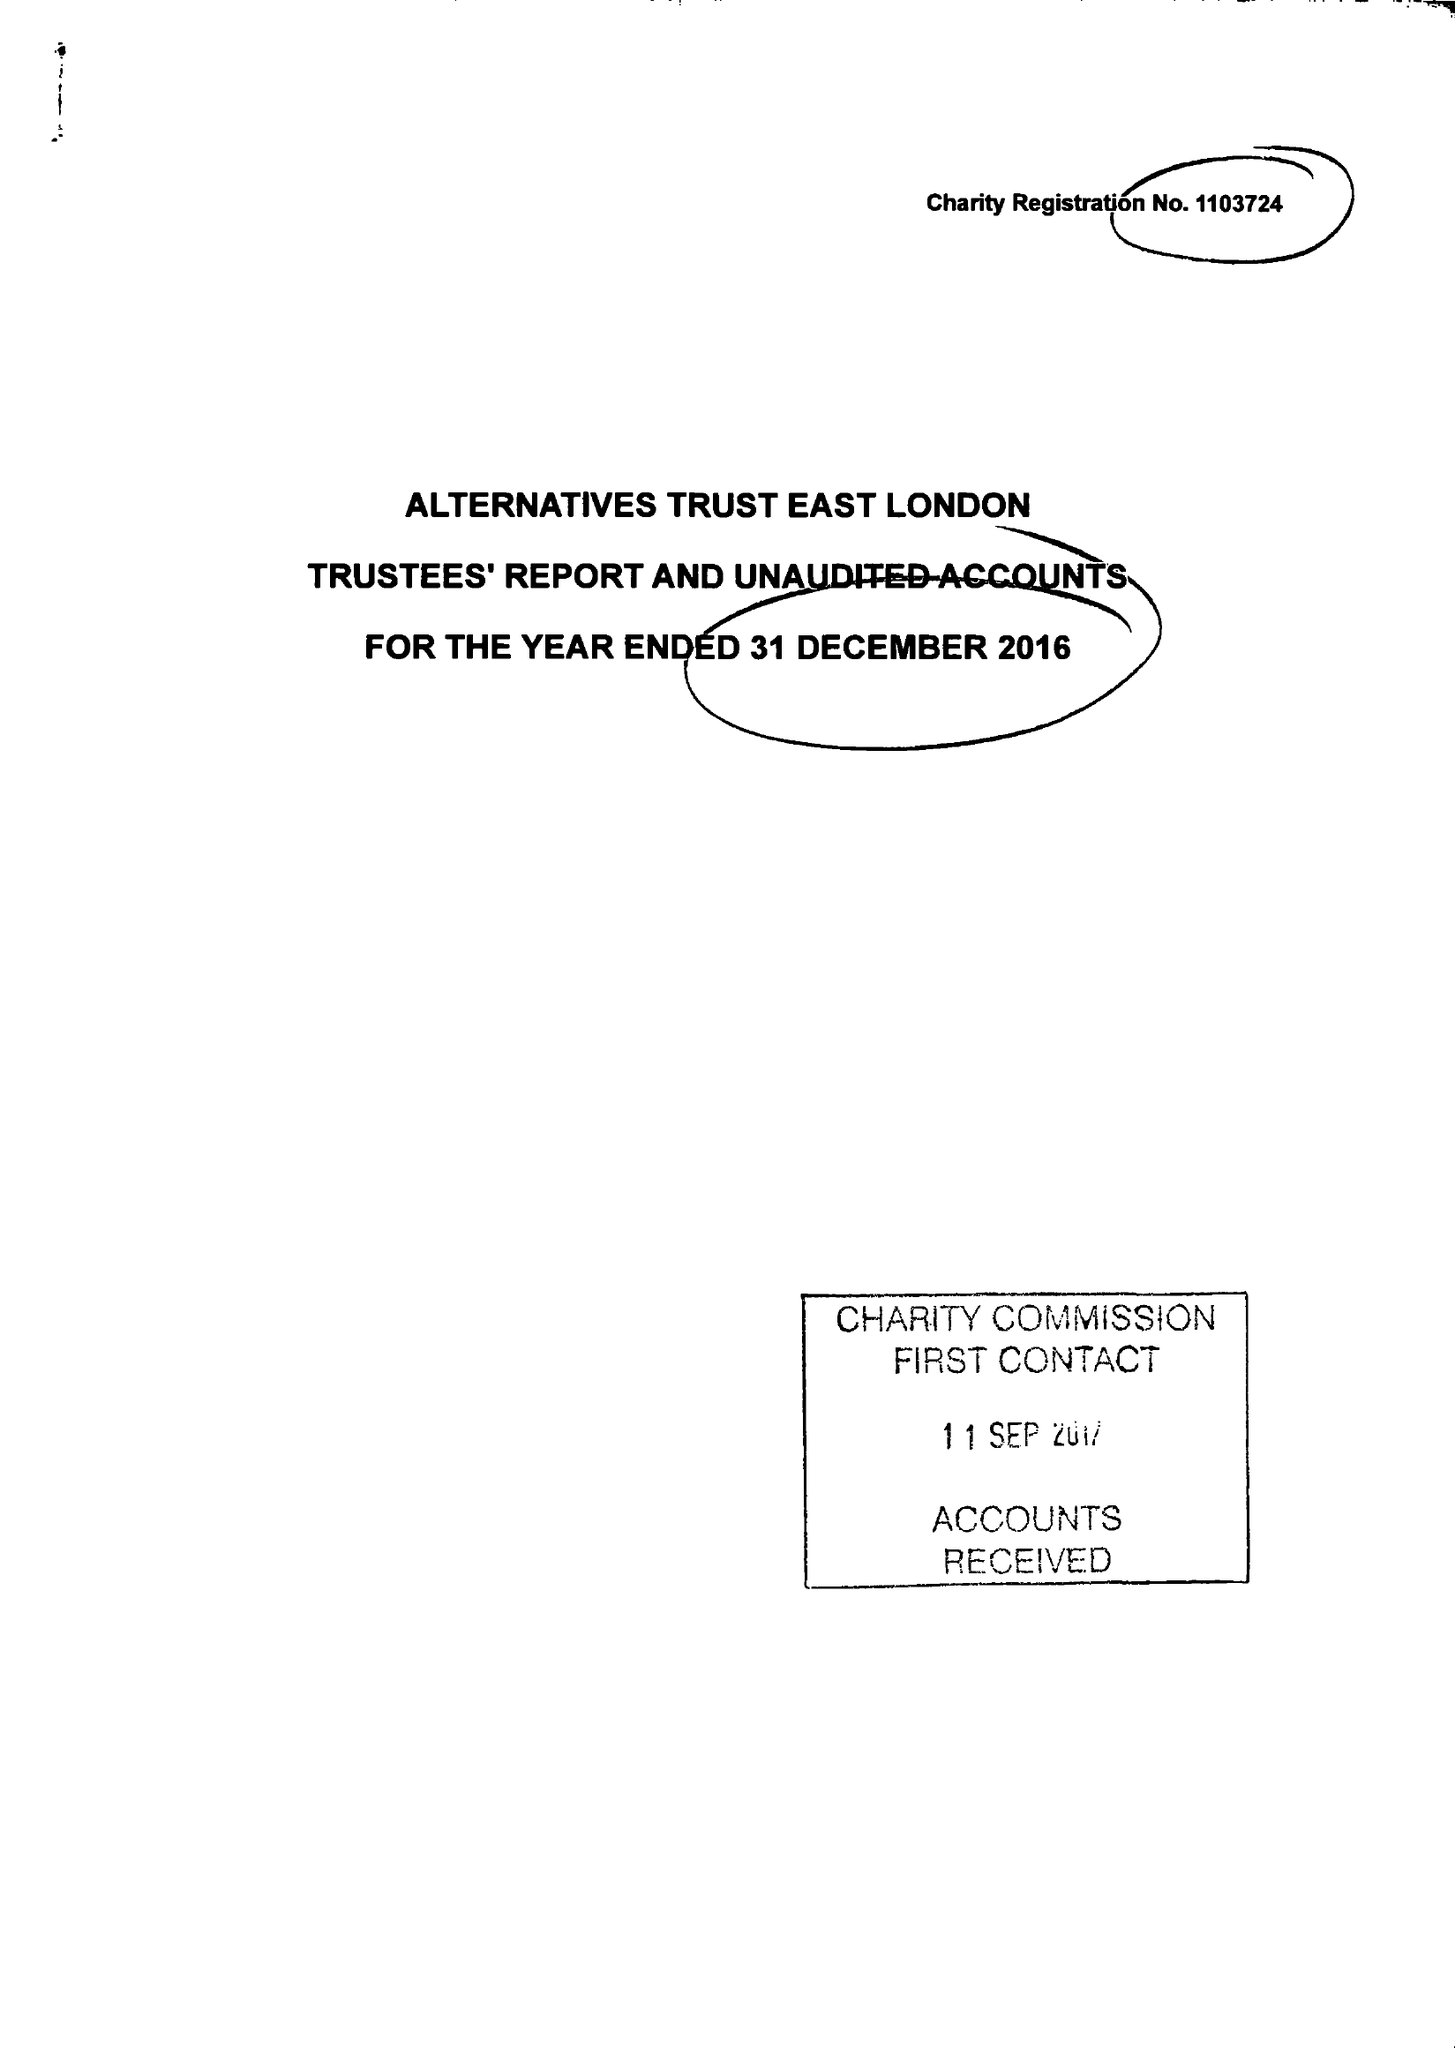What is the value for the address__postcode?
Answer the question using a single word or phrase. E13 8AB 